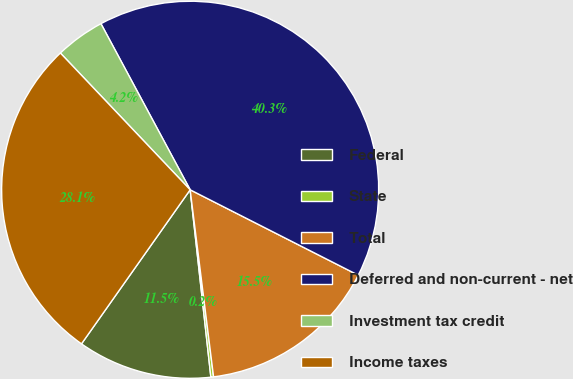<chart> <loc_0><loc_0><loc_500><loc_500><pie_chart><fcel>Federal<fcel>State<fcel>Total<fcel>Deferred and non-current - net<fcel>Investment tax credit<fcel>Income taxes<nl><fcel>11.53%<fcel>0.23%<fcel>15.54%<fcel>40.33%<fcel>4.24%<fcel>28.14%<nl></chart> 